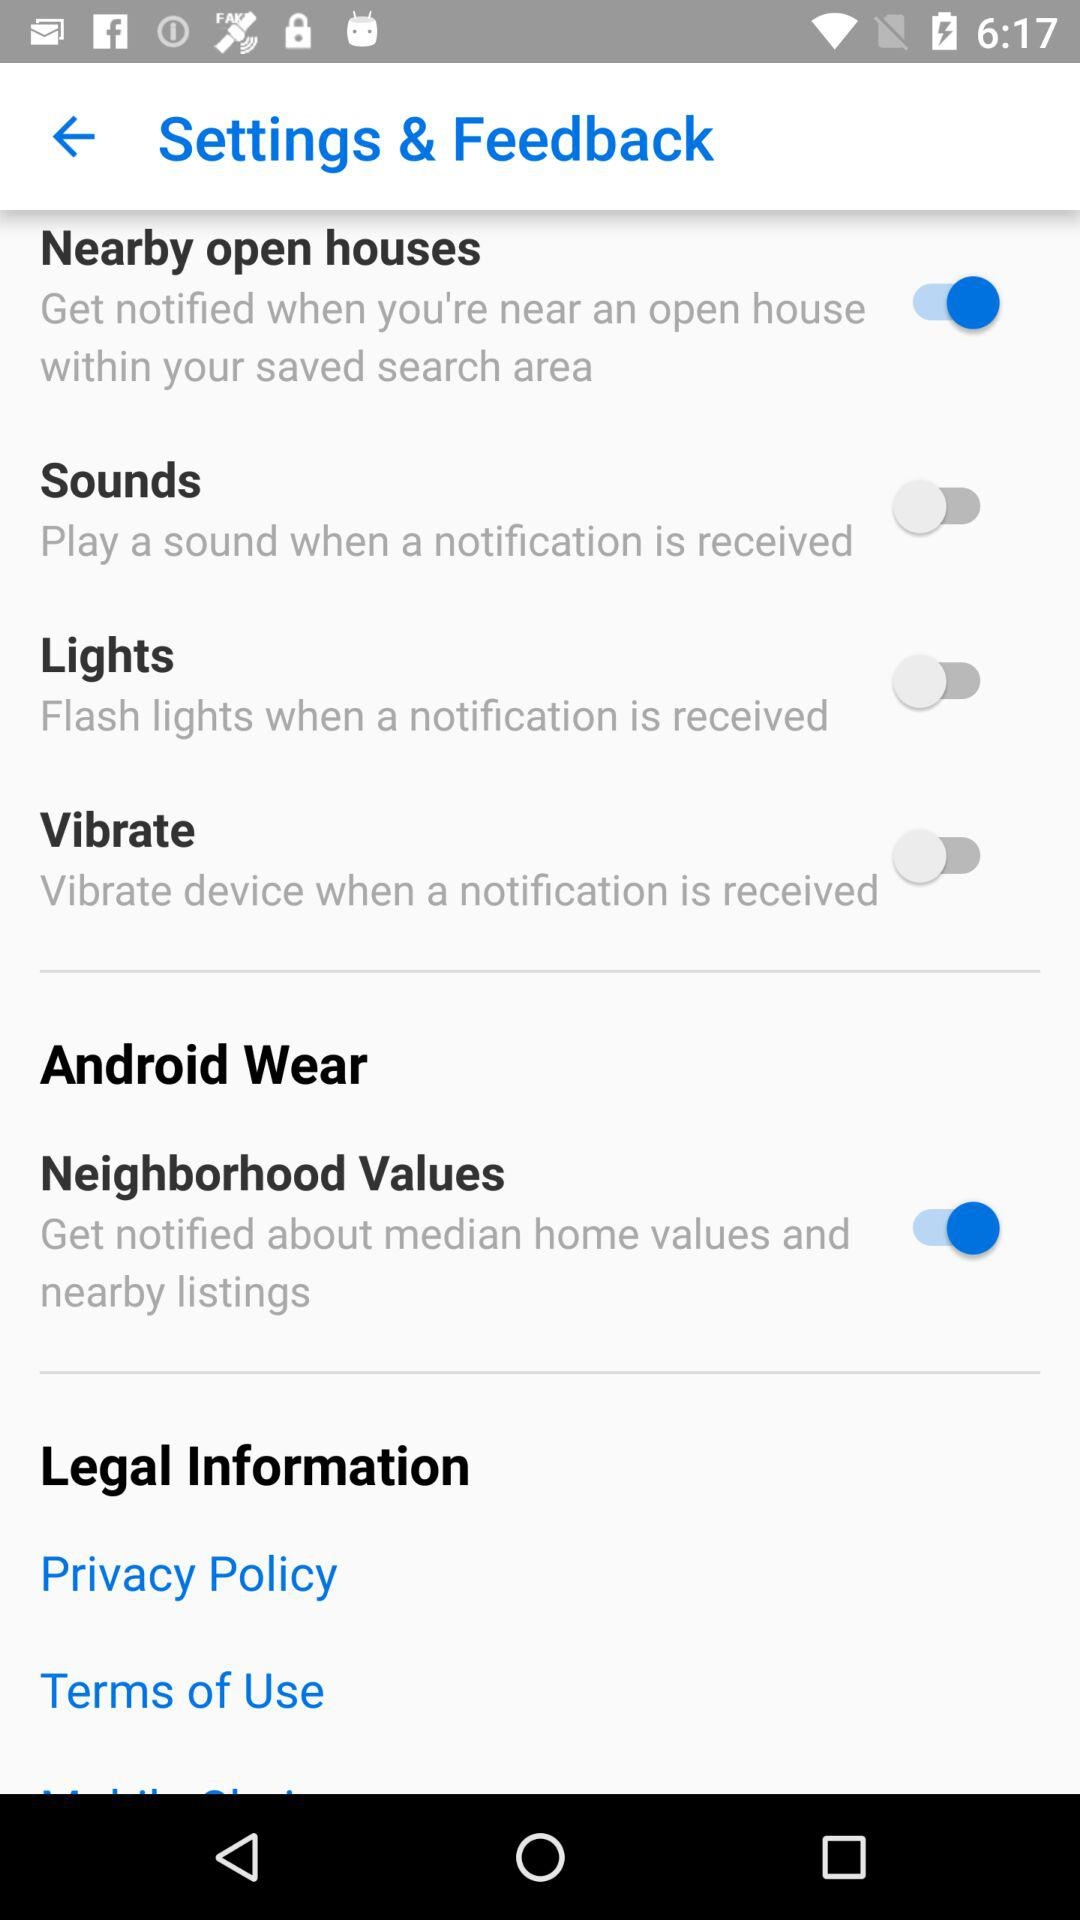Is "Android Wear" checked or unchecked?
When the provided information is insufficient, respond with <no answer>. <no answer> 